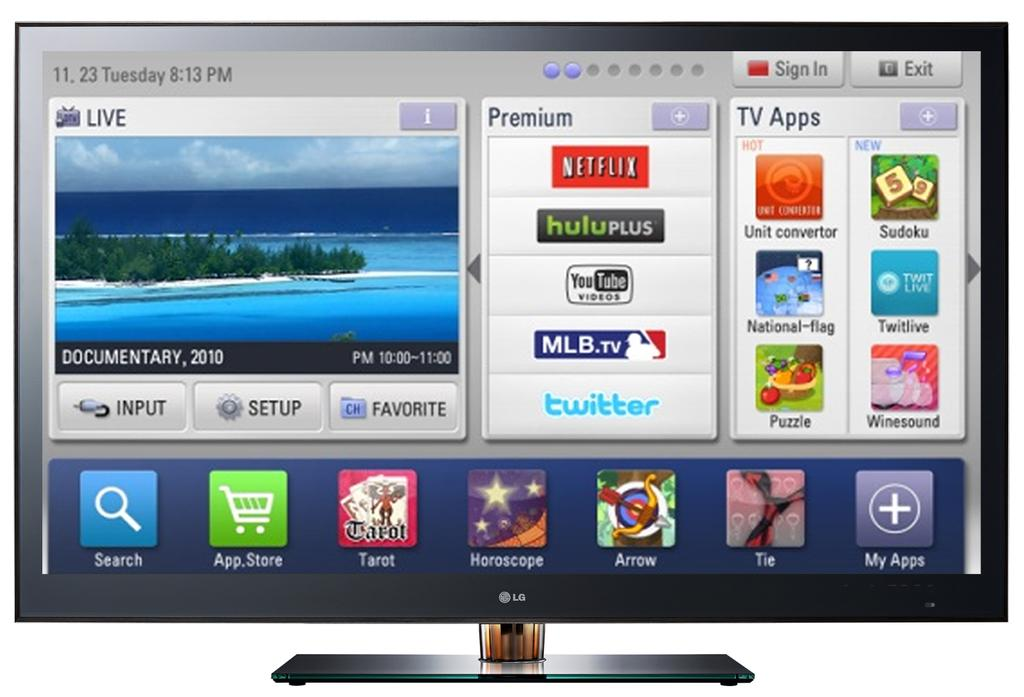<image>
Present a compact description of the photo's key features. An LG tv which is displaying different streaming services on the screen like Netflix,Huluplus, Youtube and MLB TV. 